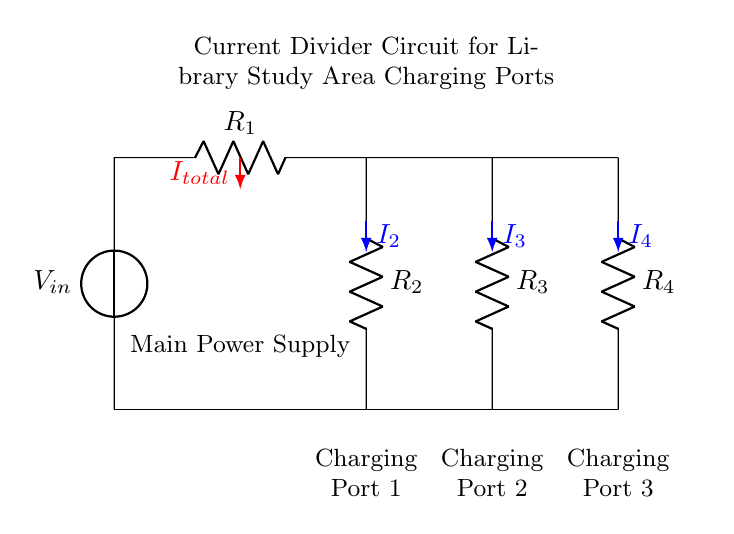What is the total current entering the circuit? The total current entering the circuit is indicated by 'I_total', which is shown in the diagram. It represents the sum of the currents flowing through the individual resistors.
Answer: I_total How many charging ports are there in this circuit? The circuit diagram clearly shows three distinct charging ports connected at the bottom. These ports are labeled Charging Port 1, Charging Port 2, and Charging Port 3.
Answer: Three What is the resistance value of R2? The circuit doesn't specify numerical values for the resistances, but 'R2' is labeled as one of the resistors connected to the charging ports. It is identified as the resistor that connects to Charging Port 1.
Answer: R2 What is the function of the currents I2, I3, and I4? The currents I2, I3, and I4 represent the individual currents flowing to each charging port. Their values will vary depending on the resistances, but they collectively divide the total current from the power supply among the ports.
Answer: Dividing currents What type of circuit is depicted here? The circuit is a current divider circuit, as indicated by its structure. It splits the incoming current into multiple branches with resistors connecting to different loads, in this case, the charging ports.
Answer: Current divider Which component serves as the main power supply? The component serving as the main power supply is labeled 'V_in', located at the top of the circuit diagram. It provides the input voltage for the current divider.
Answer: V_in 